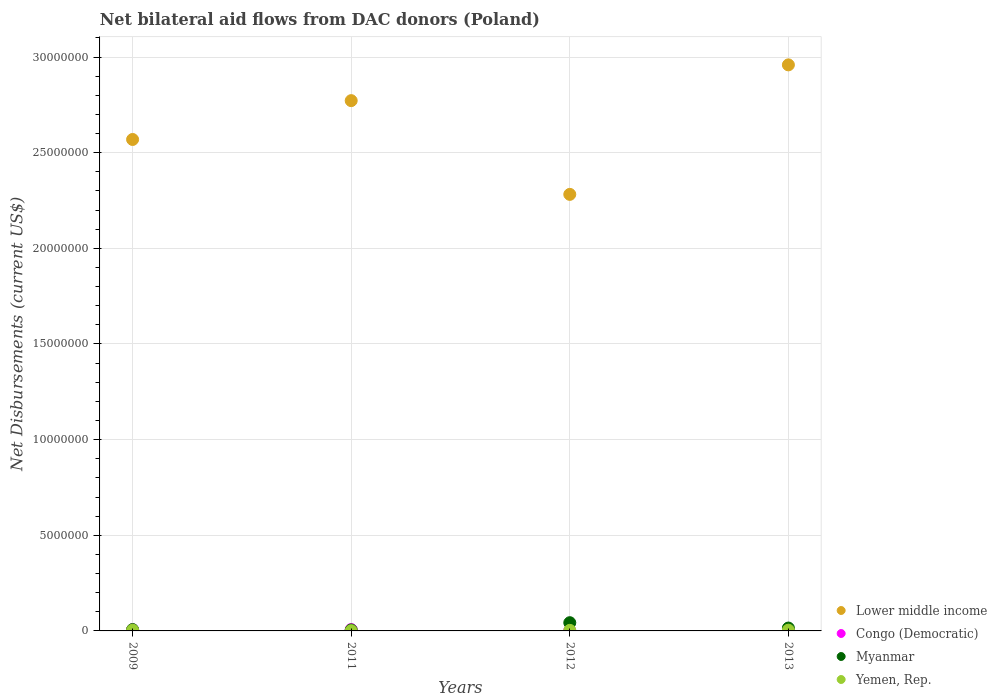How many different coloured dotlines are there?
Make the answer very short. 4. Is the number of dotlines equal to the number of legend labels?
Keep it short and to the point. Yes. What is the net bilateral aid flows in Yemen, Rep. in 2012?
Keep it short and to the point. 3.00e+04. Across all years, what is the maximum net bilateral aid flows in Congo (Democratic)?
Provide a short and direct response. 7.00e+04. Across all years, what is the minimum net bilateral aid flows in Yemen, Rep.?
Provide a succinct answer. 10000. In which year was the net bilateral aid flows in Yemen, Rep. maximum?
Give a very brief answer. 2009. In which year was the net bilateral aid flows in Yemen, Rep. minimum?
Provide a short and direct response. 2011. What is the total net bilateral aid flows in Yemen, Rep. in the graph?
Offer a very short reply. 1.20e+05. What is the difference between the net bilateral aid flows in Myanmar in 2009 and that in 2012?
Offer a very short reply. -3.60e+05. What is the difference between the net bilateral aid flows in Lower middle income in 2009 and the net bilateral aid flows in Yemen, Rep. in 2012?
Provide a short and direct response. 2.57e+07. What is the average net bilateral aid flows in Lower middle income per year?
Your answer should be compact. 2.65e+07. In the year 2009, what is the difference between the net bilateral aid flows in Myanmar and net bilateral aid flows in Yemen, Rep.?
Make the answer very short. 3.00e+04. What is the ratio of the net bilateral aid flows in Congo (Democratic) in 2009 to that in 2011?
Your response must be concise. 0.86. What is the difference between the highest and the second highest net bilateral aid flows in Lower middle income?
Ensure brevity in your answer.  1.87e+06. What is the difference between the highest and the lowest net bilateral aid flows in Congo (Democratic)?
Give a very brief answer. 5.00e+04. Is it the case that in every year, the sum of the net bilateral aid flows in Congo (Democratic) and net bilateral aid flows in Lower middle income  is greater than the net bilateral aid flows in Myanmar?
Your response must be concise. Yes. What is the difference between two consecutive major ticks on the Y-axis?
Keep it short and to the point. 5.00e+06. Are the values on the major ticks of Y-axis written in scientific E-notation?
Ensure brevity in your answer.  No. Does the graph contain any zero values?
Your answer should be very brief. No. Where does the legend appear in the graph?
Your answer should be compact. Bottom right. What is the title of the graph?
Offer a terse response. Net bilateral aid flows from DAC donors (Poland). Does "Finland" appear as one of the legend labels in the graph?
Your response must be concise. No. What is the label or title of the X-axis?
Your response must be concise. Years. What is the label or title of the Y-axis?
Your answer should be very brief. Net Disbursements (current US$). What is the Net Disbursements (current US$) of Lower middle income in 2009?
Your response must be concise. 2.57e+07. What is the Net Disbursements (current US$) in Congo (Democratic) in 2009?
Your answer should be very brief. 6.00e+04. What is the Net Disbursements (current US$) in Myanmar in 2009?
Give a very brief answer. 7.00e+04. What is the Net Disbursements (current US$) of Lower middle income in 2011?
Provide a short and direct response. 2.77e+07. What is the Net Disbursements (current US$) in Congo (Democratic) in 2011?
Give a very brief answer. 7.00e+04. What is the Net Disbursements (current US$) of Lower middle income in 2012?
Give a very brief answer. 2.28e+07. What is the Net Disbursements (current US$) in Lower middle income in 2013?
Your answer should be compact. 2.96e+07. What is the Net Disbursements (current US$) of Congo (Democratic) in 2013?
Your answer should be compact. 2.00e+04. What is the Net Disbursements (current US$) in Myanmar in 2013?
Give a very brief answer. 1.50e+05. What is the Net Disbursements (current US$) in Yemen, Rep. in 2013?
Provide a succinct answer. 4.00e+04. Across all years, what is the maximum Net Disbursements (current US$) in Lower middle income?
Make the answer very short. 2.96e+07. Across all years, what is the minimum Net Disbursements (current US$) of Lower middle income?
Keep it short and to the point. 2.28e+07. Across all years, what is the minimum Net Disbursements (current US$) of Congo (Democratic)?
Offer a very short reply. 2.00e+04. Across all years, what is the minimum Net Disbursements (current US$) in Myanmar?
Your response must be concise. 5.00e+04. Across all years, what is the minimum Net Disbursements (current US$) of Yemen, Rep.?
Ensure brevity in your answer.  10000. What is the total Net Disbursements (current US$) of Lower middle income in the graph?
Ensure brevity in your answer.  1.06e+08. What is the total Net Disbursements (current US$) in Congo (Democratic) in the graph?
Provide a succinct answer. 1.70e+05. What is the total Net Disbursements (current US$) in Yemen, Rep. in the graph?
Give a very brief answer. 1.20e+05. What is the difference between the Net Disbursements (current US$) of Lower middle income in 2009 and that in 2011?
Offer a very short reply. -2.03e+06. What is the difference between the Net Disbursements (current US$) in Congo (Democratic) in 2009 and that in 2011?
Your answer should be very brief. -10000. What is the difference between the Net Disbursements (current US$) of Myanmar in 2009 and that in 2011?
Give a very brief answer. 2.00e+04. What is the difference between the Net Disbursements (current US$) of Yemen, Rep. in 2009 and that in 2011?
Ensure brevity in your answer.  3.00e+04. What is the difference between the Net Disbursements (current US$) of Lower middle income in 2009 and that in 2012?
Your response must be concise. 2.87e+06. What is the difference between the Net Disbursements (current US$) of Congo (Democratic) in 2009 and that in 2012?
Offer a very short reply. 4.00e+04. What is the difference between the Net Disbursements (current US$) in Myanmar in 2009 and that in 2012?
Provide a short and direct response. -3.60e+05. What is the difference between the Net Disbursements (current US$) in Lower middle income in 2009 and that in 2013?
Give a very brief answer. -3.90e+06. What is the difference between the Net Disbursements (current US$) of Lower middle income in 2011 and that in 2012?
Keep it short and to the point. 4.90e+06. What is the difference between the Net Disbursements (current US$) of Myanmar in 2011 and that in 2012?
Provide a short and direct response. -3.80e+05. What is the difference between the Net Disbursements (current US$) in Lower middle income in 2011 and that in 2013?
Offer a terse response. -1.87e+06. What is the difference between the Net Disbursements (current US$) in Congo (Democratic) in 2011 and that in 2013?
Ensure brevity in your answer.  5.00e+04. What is the difference between the Net Disbursements (current US$) in Myanmar in 2011 and that in 2013?
Your answer should be very brief. -1.00e+05. What is the difference between the Net Disbursements (current US$) in Yemen, Rep. in 2011 and that in 2013?
Your answer should be very brief. -3.00e+04. What is the difference between the Net Disbursements (current US$) in Lower middle income in 2012 and that in 2013?
Offer a very short reply. -6.77e+06. What is the difference between the Net Disbursements (current US$) in Congo (Democratic) in 2012 and that in 2013?
Your answer should be compact. 0. What is the difference between the Net Disbursements (current US$) in Yemen, Rep. in 2012 and that in 2013?
Provide a succinct answer. -10000. What is the difference between the Net Disbursements (current US$) in Lower middle income in 2009 and the Net Disbursements (current US$) in Congo (Democratic) in 2011?
Give a very brief answer. 2.56e+07. What is the difference between the Net Disbursements (current US$) in Lower middle income in 2009 and the Net Disbursements (current US$) in Myanmar in 2011?
Give a very brief answer. 2.56e+07. What is the difference between the Net Disbursements (current US$) of Lower middle income in 2009 and the Net Disbursements (current US$) of Yemen, Rep. in 2011?
Offer a terse response. 2.57e+07. What is the difference between the Net Disbursements (current US$) of Congo (Democratic) in 2009 and the Net Disbursements (current US$) of Myanmar in 2011?
Your response must be concise. 10000. What is the difference between the Net Disbursements (current US$) of Congo (Democratic) in 2009 and the Net Disbursements (current US$) of Yemen, Rep. in 2011?
Your answer should be very brief. 5.00e+04. What is the difference between the Net Disbursements (current US$) in Myanmar in 2009 and the Net Disbursements (current US$) in Yemen, Rep. in 2011?
Your answer should be compact. 6.00e+04. What is the difference between the Net Disbursements (current US$) of Lower middle income in 2009 and the Net Disbursements (current US$) of Congo (Democratic) in 2012?
Provide a short and direct response. 2.57e+07. What is the difference between the Net Disbursements (current US$) of Lower middle income in 2009 and the Net Disbursements (current US$) of Myanmar in 2012?
Provide a short and direct response. 2.53e+07. What is the difference between the Net Disbursements (current US$) in Lower middle income in 2009 and the Net Disbursements (current US$) in Yemen, Rep. in 2012?
Make the answer very short. 2.57e+07. What is the difference between the Net Disbursements (current US$) in Congo (Democratic) in 2009 and the Net Disbursements (current US$) in Myanmar in 2012?
Ensure brevity in your answer.  -3.70e+05. What is the difference between the Net Disbursements (current US$) in Myanmar in 2009 and the Net Disbursements (current US$) in Yemen, Rep. in 2012?
Give a very brief answer. 4.00e+04. What is the difference between the Net Disbursements (current US$) in Lower middle income in 2009 and the Net Disbursements (current US$) in Congo (Democratic) in 2013?
Offer a very short reply. 2.57e+07. What is the difference between the Net Disbursements (current US$) in Lower middle income in 2009 and the Net Disbursements (current US$) in Myanmar in 2013?
Your answer should be compact. 2.55e+07. What is the difference between the Net Disbursements (current US$) of Lower middle income in 2009 and the Net Disbursements (current US$) of Yemen, Rep. in 2013?
Offer a terse response. 2.56e+07. What is the difference between the Net Disbursements (current US$) of Myanmar in 2009 and the Net Disbursements (current US$) of Yemen, Rep. in 2013?
Give a very brief answer. 3.00e+04. What is the difference between the Net Disbursements (current US$) in Lower middle income in 2011 and the Net Disbursements (current US$) in Congo (Democratic) in 2012?
Provide a succinct answer. 2.77e+07. What is the difference between the Net Disbursements (current US$) of Lower middle income in 2011 and the Net Disbursements (current US$) of Myanmar in 2012?
Your response must be concise. 2.73e+07. What is the difference between the Net Disbursements (current US$) in Lower middle income in 2011 and the Net Disbursements (current US$) in Yemen, Rep. in 2012?
Give a very brief answer. 2.77e+07. What is the difference between the Net Disbursements (current US$) in Congo (Democratic) in 2011 and the Net Disbursements (current US$) in Myanmar in 2012?
Your answer should be compact. -3.60e+05. What is the difference between the Net Disbursements (current US$) in Lower middle income in 2011 and the Net Disbursements (current US$) in Congo (Democratic) in 2013?
Offer a terse response. 2.77e+07. What is the difference between the Net Disbursements (current US$) of Lower middle income in 2011 and the Net Disbursements (current US$) of Myanmar in 2013?
Give a very brief answer. 2.76e+07. What is the difference between the Net Disbursements (current US$) in Lower middle income in 2011 and the Net Disbursements (current US$) in Yemen, Rep. in 2013?
Give a very brief answer. 2.77e+07. What is the difference between the Net Disbursements (current US$) in Congo (Democratic) in 2011 and the Net Disbursements (current US$) in Myanmar in 2013?
Offer a terse response. -8.00e+04. What is the difference between the Net Disbursements (current US$) of Myanmar in 2011 and the Net Disbursements (current US$) of Yemen, Rep. in 2013?
Provide a succinct answer. 10000. What is the difference between the Net Disbursements (current US$) in Lower middle income in 2012 and the Net Disbursements (current US$) in Congo (Democratic) in 2013?
Provide a short and direct response. 2.28e+07. What is the difference between the Net Disbursements (current US$) in Lower middle income in 2012 and the Net Disbursements (current US$) in Myanmar in 2013?
Offer a terse response. 2.27e+07. What is the difference between the Net Disbursements (current US$) of Lower middle income in 2012 and the Net Disbursements (current US$) of Yemen, Rep. in 2013?
Offer a terse response. 2.28e+07. What is the difference between the Net Disbursements (current US$) in Congo (Democratic) in 2012 and the Net Disbursements (current US$) in Myanmar in 2013?
Your answer should be compact. -1.30e+05. What is the difference between the Net Disbursements (current US$) of Congo (Democratic) in 2012 and the Net Disbursements (current US$) of Yemen, Rep. in 2013?
Offer a very short reply. -2.00e+04. What is the average Net Disbursements (current US$) of Lower middle income per year?
Your answer should be very brief. 2.65e+07. What is the average Net Disbursements (current US$) in Congo (Democratic) per year?
Ensure brevity in your answer.  4.25e+04. What is the average Net Disbursements (current US$) of Myanmar per year?
Provide a succinct answer. 1.75e+05. In the year 2009, what is the difference between the Net Disbursements (current US$) in Lower middle income and Net Disbursements (current US$) in Congo (Democratic)?
Offer a terse response. 2.56e+07. In the year 2009, what is the difference between the Net Disbursements (current US$) of Lower middle income and Net Disbursements (current US$) of Myanmar?
Your answer should be very brief. 2.56e+07. In the year 2009, what is the difference between the Net Disbursements (current US$) in Lower middle income and Net Disbursements (current US$) in Yemen, Rep.?
Your answer should be very brief. 2.56e+07. In the year 2011, what is the difference between the Net Disbursements (current US$) in Lower middle income and Net Disbursements (current US$) in Congo (Democratic)?
Keep it short and to the point. 2.76e+07. In the year 2011, what is the difference between the Net Disbursements (current US$) of Lower middle income and Net Disbursements (current US$) of Myanmar?
Give a very brief answer. 2.77e+07. In the year 2011, what is the difference between the Net Disbursements (current US$) of Lower middle income and Net Disbursements (current US$) of Yemen, Rep.?
Provide a succinct answer. 2.77e+07. In the year 2011, what is the difference between the Net Disbursements (current US$) in Congo (Democratic) and Net Disbursements (current US$) in Myanmar?
Ensure brevity in your answer.  2.00e+04. In the year 2011, what is the difference between the Net Disbursements (current US$) in Myanmar and Net Disbursements (current US$) in Yemen, Rep.?
Your answer should be compact. 4.00e+04. In the year 2012, what is the difference between the Net Disbursements (current US$) of Lower middle income and Net Disbursements (current US$) of Congo (Democratic)?
Offer a very short reply. 2.28e+07. In the year 2012, what is the difference between the Net Disbursements (current US$) of Lower middle income and Net Disbursements (current US$) of Myanmar?
Your answer should be compact. 2.24e+07. In the year 2012, what is the difference between the Net Disbursements (current US$) in Lower middle income and Net Disbursements (current US$) in Yemen, Rep.?
Your response must be concise. 2.28e+07. In the year 2012, what is the difference between the Net Disbursements (current US$) in Congo (Democratic) and Net Disbursements (current US$) in Myanmar?
Offer a very short reply. -4.10e+05. In the year 2012, what is the difference between the Net Disbursements (current US$) in Congo (Democratic) and Net Disbursements (current US$) in Yemen, Rep.?
Your answer should be very brief. -10000. In the year 2013, what is the difference between the Net Disbursements (current US$) of Lower middle income and Net Disbursements (current US$) of Congo (Democratic)?
Keep it short and to the point. 2.96e+07. In the year 2013, what is the difference between the Net Disbursements (current US$) in Lower middle income and Net Disbursements (current US$) in Myanmar?
Provide a succinct answer. 2.94e+07. In the year 2013, what is the difference between the Net Disbursements (current US$) of Lower middle income and Net Disbursements (current US$) of Yemen, Rep.?
Make the answer very short. 2.96e+07. What is the ratio of the Net Disbursements (current US$) of Lower middle income in 2009 to that in 2011?
Your answer should be compact. 0.93. What is the ratio of the Net Disbursements (current US$) in Congo (Democratic) in 2009 to that in 2011?
Your answer should be compact. 0.86. What is the ratio of the Net Disbursements (current US$) in Yemen, Rep. in 2009 to that in 2011?
Ensure brevity in your answer.  4. What is the ratio of the Net Disbursements (current US$) in Lower middle income in 2009 to that in 2012?
Provide a short and direct response. 1.13. What is the ratio of the Net Disbursements (current US$) of Congo (Democratic) in 2009 to that in 2012?
Provide a succinct answer. 3. What is the ratio of the Net Disbursements (current US$) in Myanmar in 2009 to that in 2012?
Make the answer very short. 0.16. What is the ratio of the Net Disbursements (current US$) in Lower middle income in 2009 to that in 2013?
Your answer should be very brief. 0.87. What is the ratio of the Net Disbursements (current US$) of Myanmar in 2009 to that in 2013?
Provide a short and direct response. 0.47. What is the ratio of the Net Disbursements (current US$) of Lower middle income in 2011 to that in 2012?
Give a very brief answer. 1.21. What is the ratio of the Net Disbursements (current US$) in Myanmar in 2011 to that in 2012?
Offer a terse response. 0.12. What is the ratio of the Net Disbursements (current US$) of Yemen, Rep. in 2011 to that in 2012?
Ensure brevity in your answer.  0.33. What is the ratio of the Net Disbursements (current US$) in Lower middle income in 2011 to that in 2013?
Provide a short and direct response. 0.94. What is the ratio of the Net Disbursements (current US$) of Congo (Democratic) in 2011 to that in 2013?
Give a very brief answer. 3.5. What is the ratio of the Net Disbursements (current US$) of Myanmar in 2011 to that in 2013?
Your answer should be compact. 0.33. What is the ratio of the Net Disbursements (current US$) of Yemen, Rep. in 2011 to that in 2013?
Your answer should be very brief. 0.25. What is the ratio of the Net Disbursements (current US$) of Lower middle income in 2012 to that in 2013?
Ensure brevity in your answer.  0.77. What is the ratio of the Net Disbursements (current US$) of Congo (Democratic) in 2012 to that in 2013?
Your answer should be compact. 1. What is the ratio of the Net Disbursements (current US$) of Myanmar in 2012 to that in 2013?
Your answer should be compact. 2.87. What is the ratio of the Net Disbursements (current US$) in Yemen, Rep. in 2012 to that in 2013?
Offer a terse response. 0.75. What is the difference between the highest and the second highest Net Disbursements (current US$) of Lower middle income?
Keep it short and to the point. 1.87e+06. What is the difference between the highest and the lowest Net Disbursements (current US$) of Lower middle income?
Provide a succinct answer. 6.77e+06. What is the difference between the highest and the lowest Net Disbursements (current US$) of Congo (Democratic)?
Your answer should be compact. 5.00e+04. What is the difference between the highest and the lowest Net Disbursements (current US$) in Myanmar?
Keep it short and to the point. 3.80e+05. What is the difference between the highest and the lowest Net Disbursements (current US$) in Yemen, Rep.?
Your answer should be very brief. 3.00e+04. 